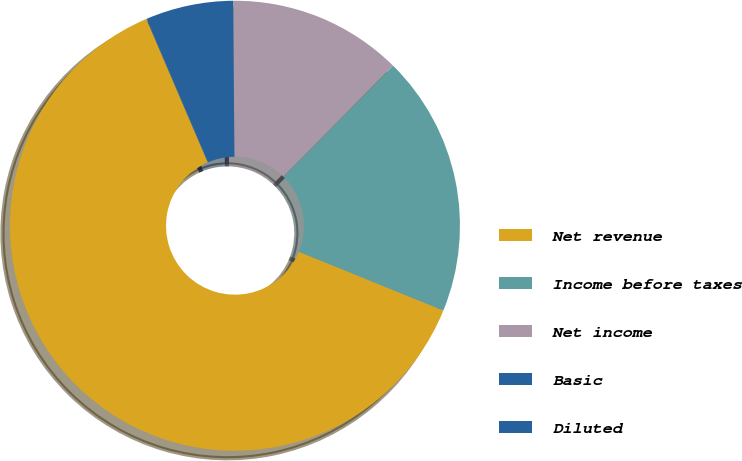Convert chart. <chart><loc_0><loc_0><loc_500><loc_500><pie_chart><fcel>Net revenue<fcel>Income before taxes<fcel>Net income<fcel>Basic<fcel>Diluted<nl><fcel>62.41%<fcel>18.75%<fcel>12.52%<fcel>6.28%<fcel>0.04%<nl></chart> 